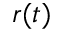Convert formula to latex. <formula><loc_0><loc_0><loc_500><loc_500>r ( t )</formula> 